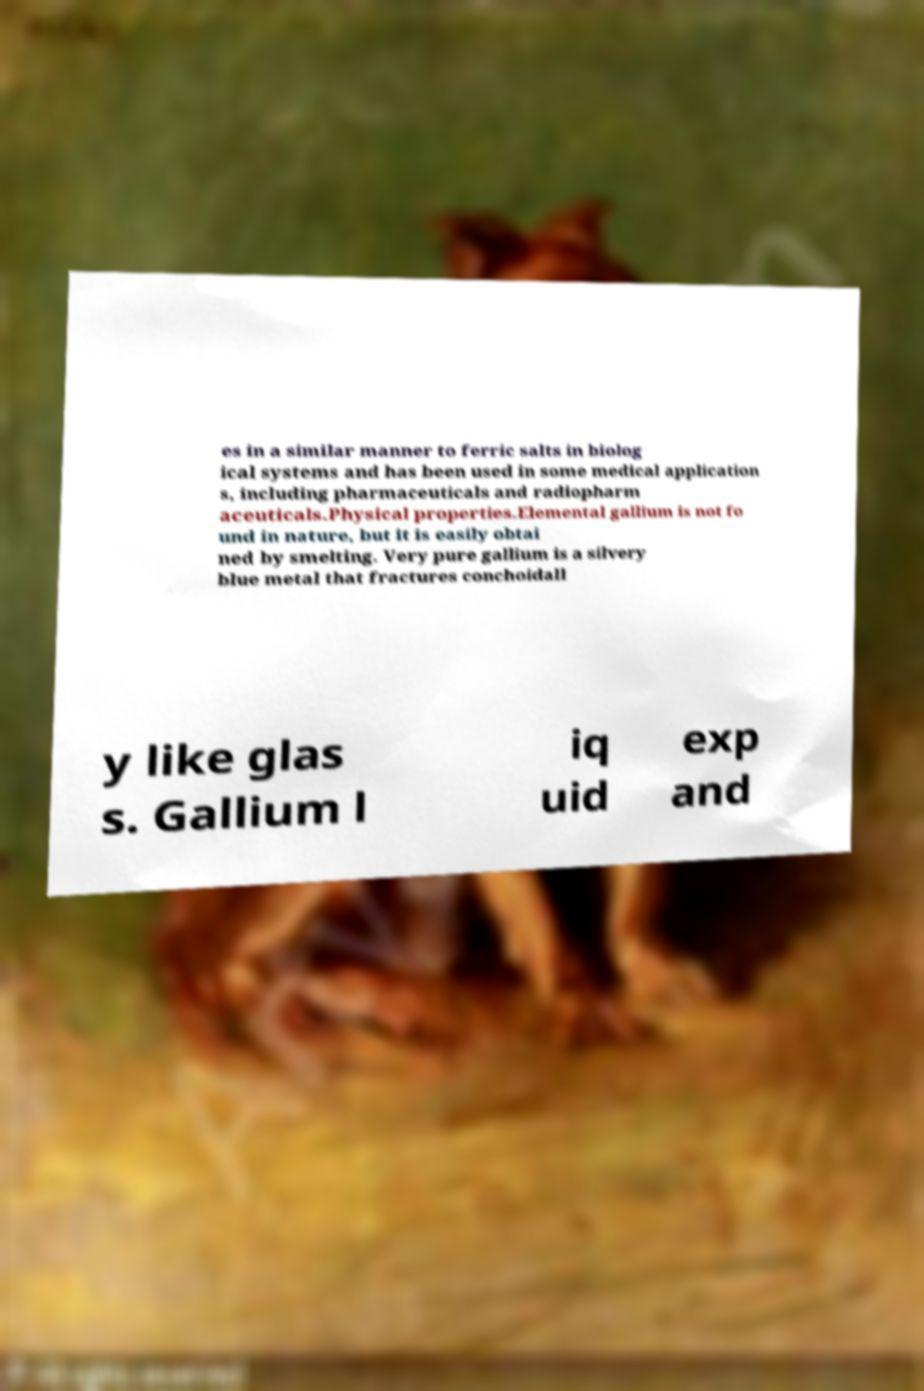Can you accurately transcribe the text from the provided image for me? es in a similar manner to ferric salts in biolog ical systems and has been used in some medical application s, including pharmaceuticals and radiopharm aceuticals.Physical properties.Elemental gallium is not fo und in nature, but it is easily obtai ned by smelting. Very pure gallium is a silvery blue metal that fractures conchoidall y like glas s. Gallium l iq uid exp and 